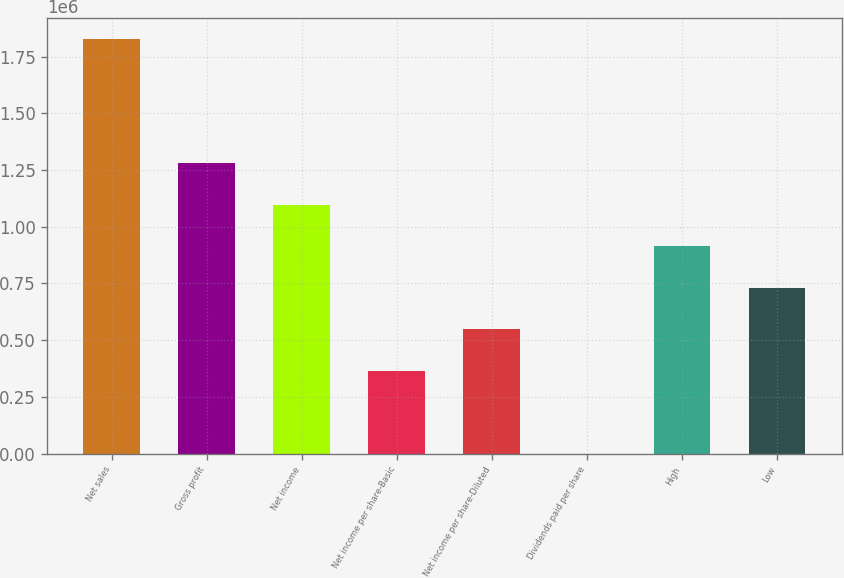Convert chart to OTSL. <chart><loc_0><loc_0><loc_500><loc_500><bar_chart><fcel>Net sales<fcel>Gross profit<fcel>Net income<fcel>Net income per share-Basic<fcel>Net income per share-Diluted<fcel>Dividends paid per share<fcel>High<fcel>Low<nl><fcel>1.82743e+06<fcel>1.2792e+06<fcel>1.09646e+06<fcel>365486<fcel>548228<fcel>0.38<fcel>913713<fcel>730971<nl></chart> 